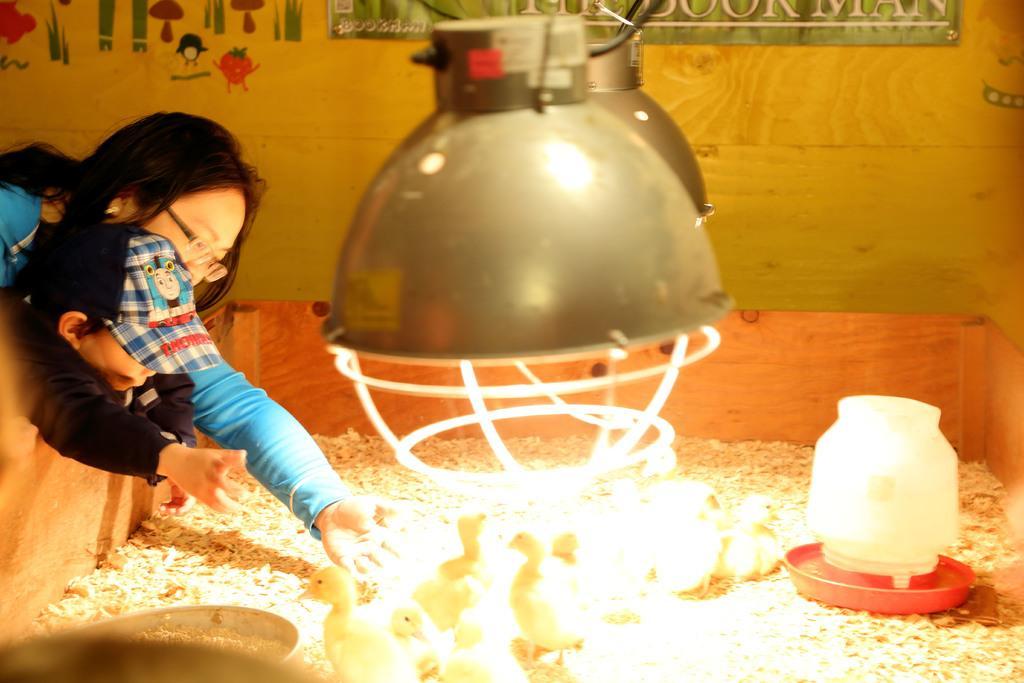How would you summarize this image in a sentence or two? This picture shows few chickens in the box and we see few bowls and we see a woman and a boy trying to catch a chicken and we see a wooden wall and couple of lights hanging. 